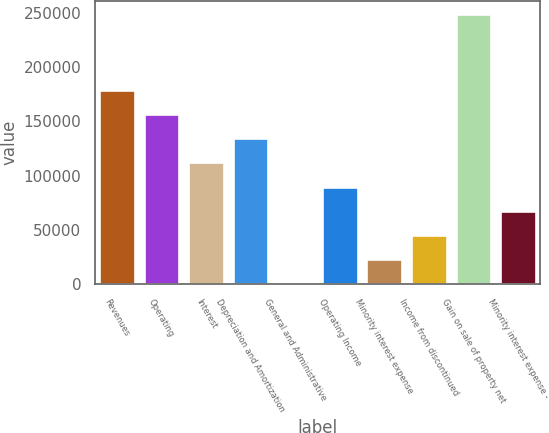Convert chart. <chart><loc_0><loc_0><loc_500><loc_500><bar_chart><fcel>Revenues<fcel>Operating<fcel>Interest<fcel>Depreciation and Amortization<fcel>General and Administrative<fcel>Operating Income<fcel>Minority interest expense<fcel>Income from discontinued<fcel>Gain on sale of property net<fcel>Minority interest expense -<nl><fcel>179138<fcel>156778<fcel>112058<fcel>134418<fcel>257<fcel>89697.4<fcel>22617.1<fcel>44977.2<fcel>249013<fcel>67337.3<nl></chart> 